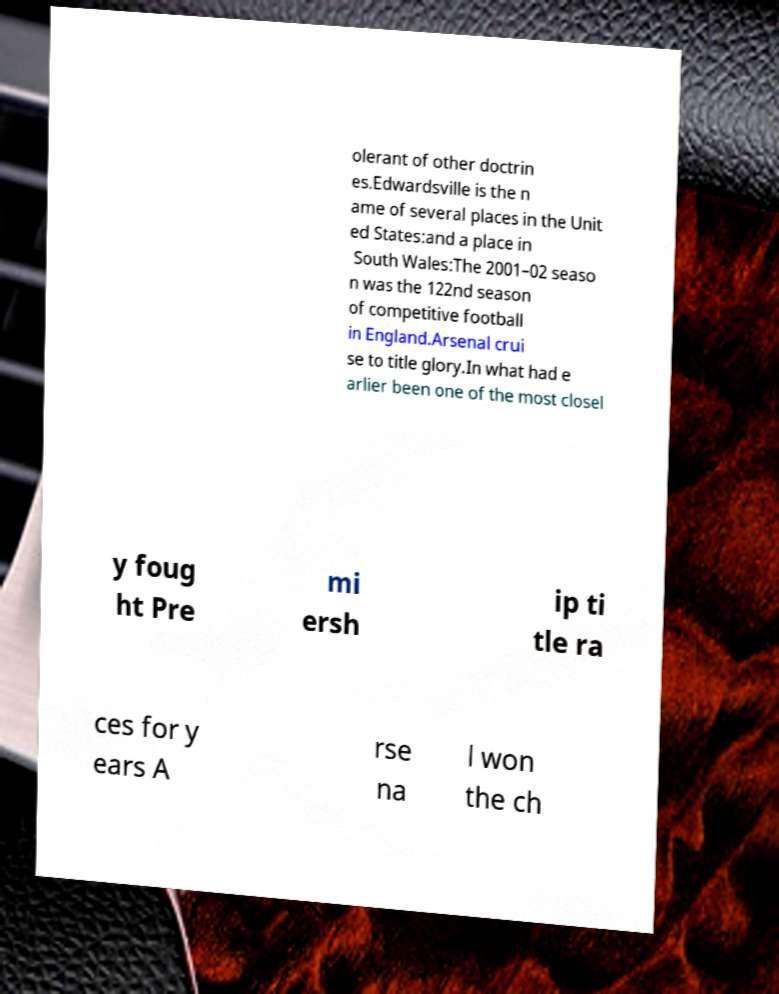Please read and relay the text visible in this image. What does it say? olerant of other doctrin es.Edwardsville is the n ame of several places in the Unit ed States:and a place in South Wales:The 2001–02 seaso n was the 122nd season of competitive football in England.Arsenal crui se to title glory.In what had e arlier been one of the most closel y foug ht Pre mi ersh ip ti tle ra ces for y ears A rse na l won the ch 